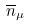Convert formula to latex. <formula><loc_0><loc_0><loc_500><loc_500>\overline { n } _ { \mu }</formula> 